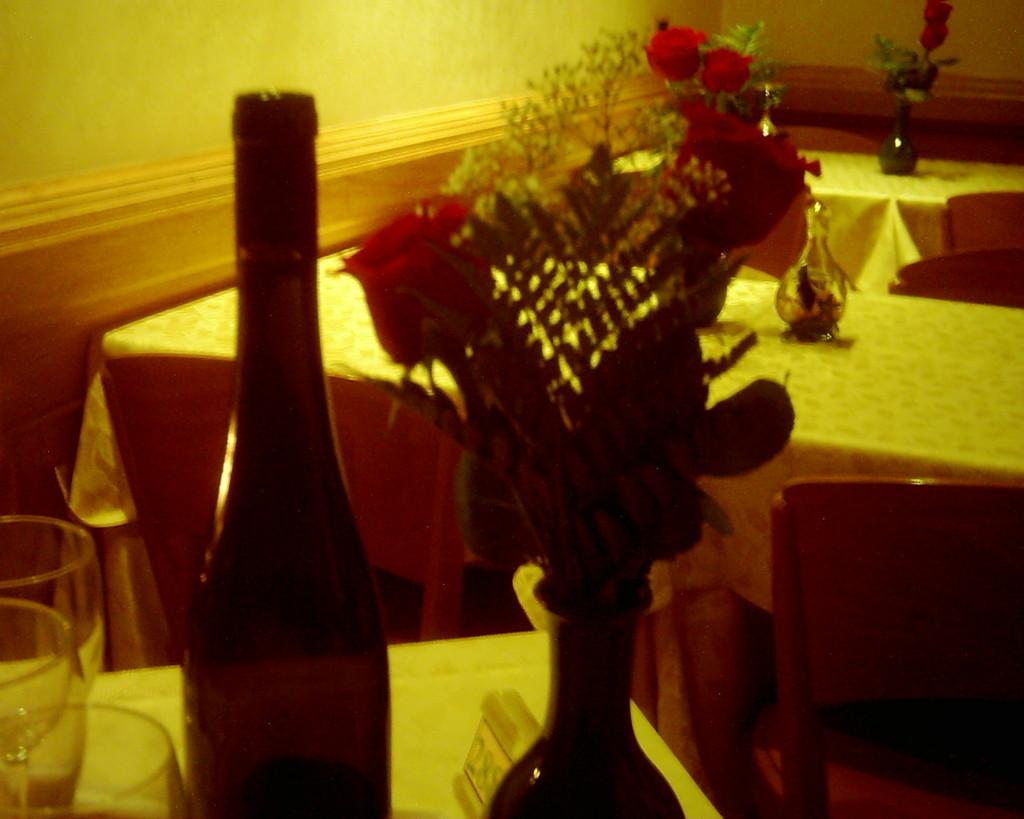What type of furniture is present in the image? There are tables and chairs in the image. What can be found on the table in the image? There is a flower vase with flowers and a bottle on the table. Are there any drinking vessels on the table? Yes, there are glasses on the table. What type of musical instrument is being played in the image? There is no musical instrument present in the image. What type of shade is covering the tables in the image? There is no shade covering the tables in the image; the tables and chairs are in an open area. 